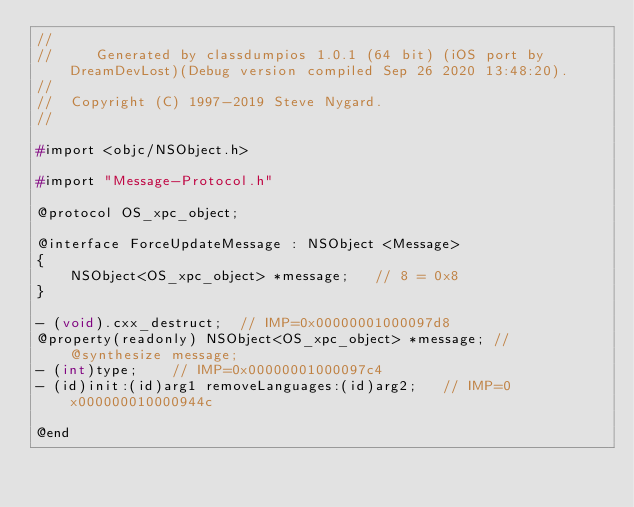<code> <loc_0><loc_0><loc_500><loc_500><_C_>//
//     Generated by classdumpios 1.0.1 (64 bit) (iOS port by DreamDevLost)(Debug version compiled Sep 26 2020 13:48:20).
//
//  Copyright (C) 1997-2019 Steve Nygard.
//

#import <objc/NSObject.h>

#import "Message-Protocol.h"

@protocol OS_xpc_object;

@interface ForceUpdateMessage : NSObject <Message>
{
    NSObject<OS_xpc_object> *message;	// 8 = 0x8
}

- (void).cxx_destruct;	// IMP=0x00000001000097d8
@property(readonly) NSObject<OS_xpc_object> *message; // @synthesize message;
- (int)type;	// IMP=0x00000001000097c4
- (id)init:(id)arg1 removeLanguages:(id)arg2;	// IMP=0x000000010000944c

@end

</code> 